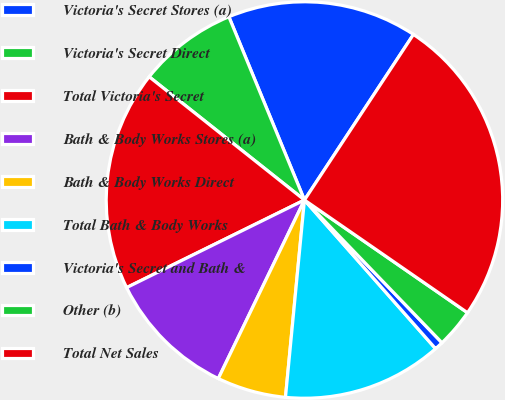Convert chart to OTSL. <chart><loc_0><loc_0><loc_500><loc_500><pie_chart><fcel>Victoria's Secret Stores (a)<fcel>Victoria's Secret Direct<fcel>Total Victoria's Secret<fcel>Bath & Body Works Stores (a)<fcel>Bath & Body Works Direct<fcel>Total Bath & Body Works<fcel>Victoria's Secret and Bath &<fcel>Other (b)<fcel>Total Net Sales<nl><fcel>15.49%<fcel>8.1%<fcel>17.96%<fcel>10.56%<fcel>5.63%<fcel>13.03%<fcel>0.7%<fcel>3.17%<fcel>25.36%<nl></chart> 